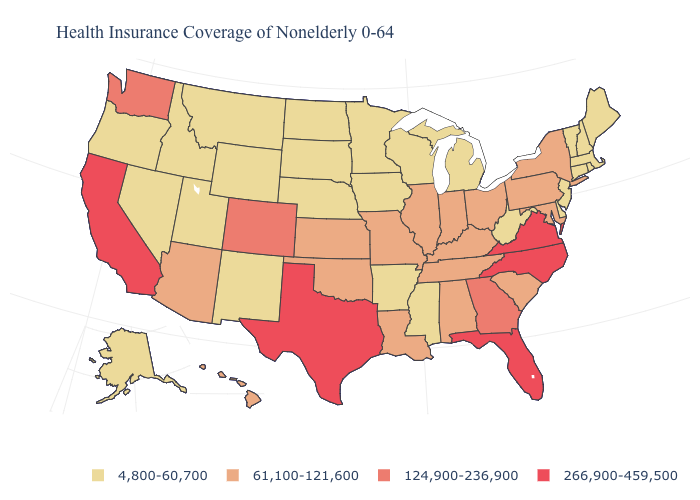What is the lowest value in the USA?
Quick response, please. 4,800-60,700. What is the value of Tennessee?
Be succinct. 61,100-121,600. Name the states that have a value in the range 61,100-121,600?
Answer briefly. Alabama, Arizona, Hawaii, Illinois, Indiana, Kansas, Kentucky, Louisiana, Maryland, Missouri, New York, Ohio, Oklahoma, Pennsylvania, South Carolina, Tennessee. Does Illinois have the lowest value in the MidWest?
Write a very short answer. No. What is the value of Minnesota?
Write a very short answer. 4,800-60,700. Which states hav the highest value in the South?
Concise answer only. Florida, North Carolina, Texas, Virginia. Which states have the lowest value in the West?
Answer briefly. Alaska, Idaho, Montana, Nevada, New Mexico, Oregon, Utah, Wyoming. Name the states that have a value in the range 266,900-459,500?
Concise answer only. California, Florida, North Carolina, Texas, Virginia. What is the value of Massachusetts?
Short answer required. 4,800-60,700. Name the states that have a value in the range 266,900-459,500?
Keep it brief. California, Florida, North Carolina, Texas, Virginia. Does the map have missing data?
Keep it brief. No. Does Virginia have the highest value in the USA?
Quick response, please. Yes. What is the value of Colorado?
Write a very short answer. 124,900-236,900. What is the lowest value in the South?
Quick response, please. 4,800-60,700. What is the value of Montana?
Short answer required. 4,800-60,700. 